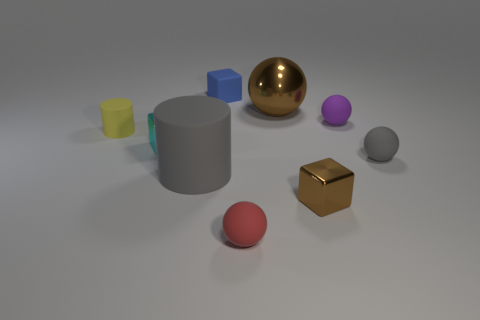Subtract all spheres. How many objects are left? 5 Subtract all big green objects. Subtract all brown cubes. How many objects are left? 8 Add 6 shiny cubes. How many shiny cubes are left? 8 Add 9 small purple rubber spheres. How many small purple rubber spheres exist? 10 Subtract 0 cyan cylinders. How many objects are left? 9 